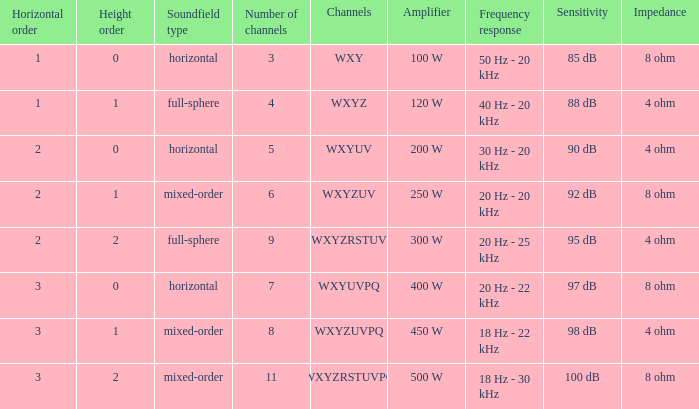If the channels is wxyzuv, what is the number of channels? 6.0. 